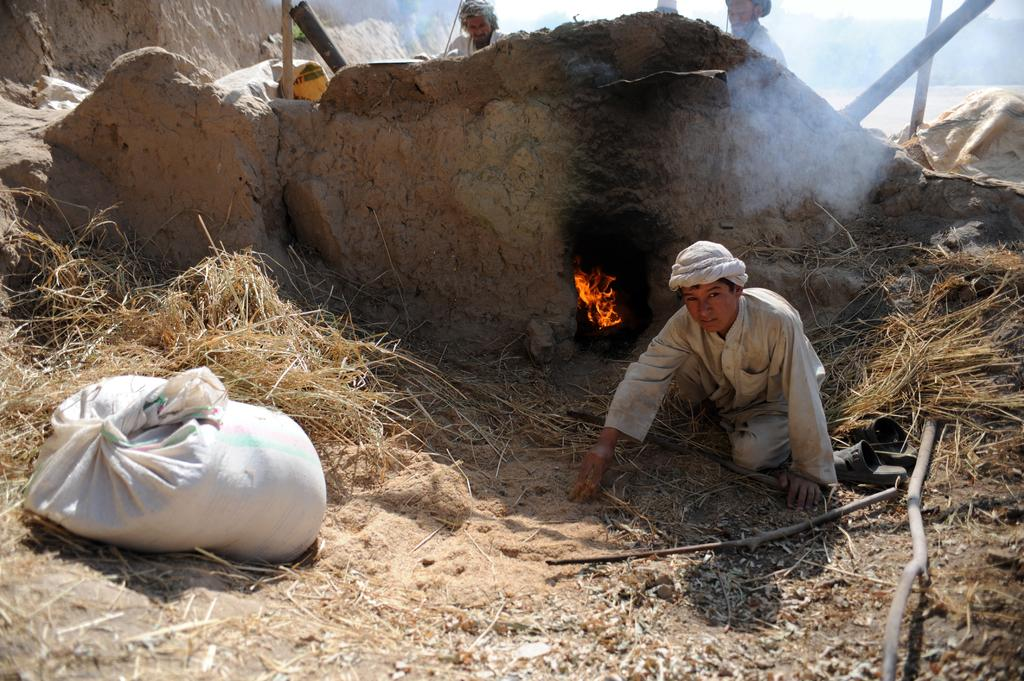What is the position of the person in the image? There is a person sitting on the ground in the image. What can be seen on the left side of the image? There is a bag on the left side of the image. What is the source of light in the image? There is fire visible in the image, which could be the source of light. How many people are standing in the background of the image? There are two persons standing in the background of the image. What type of blade is being used to cut the engine in the image? There is no blade or engine present in the image. What type of lamp is illuminating the scene in the image? There is no lamp present in the image; the source of light is the fire. 